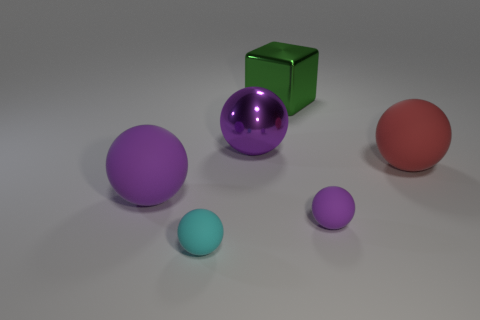Is there any other thing that is the same shape as the big green object?
Your answer should be compact. No. What is the color of the large object that is both in front of the metal ball and right of the large purple matte sphere?
Your response must be concise. Red. What shape is the purple matte object that is the same size as the red rubber object?
Your answer should be compact. Sphere. Is there a small cyan matte object of the same shape as the small purple object?
Ensure brevity in your answer.  Yes. Is the material of the green thing the same as the purple thing left of the purple shiny sphere?
Provide a succinct answer. No. What color is the big ball that is in front of the large rubber sphere on the right side of the big matte sphere that is on the left side of the red matte sphere?
Give a very brief answer. Purple. There is a purple object that is the same size as the cyan rubber thing; what material is it?
Your answer should be compact. Rubber. What number of tiny cyan spheres have the same material as the block?
Offer a very short reply. 0. There is a purple thing that is on the right side of the purple shiny ball; is its size the same as the ball in front of the tiny purple ball?
Keep it short and to the point. Yes. There is a big matte sphere on the left side of the cyan matte sphere; what color is it?
Provide a succinct answer. Purple. 